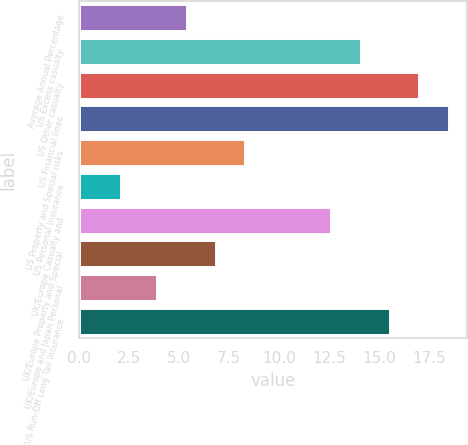Convert chart. <chart><loc_0><loc_0><loc_500><loc_500><bar_chart><fcel>Average Annual Percentage<fcel>US Excess casualty<fcel>US Other casualty<fcel>US Financial lines<fcel>US Property and Special risks<fcel>US Personal Insurance<fcel>UK/Europe Casualty and<fcel>UK/Europe Property and Special<fcel>UK/Europe and Japan Personal<fcel>US Run-Off Long Tail Insurance<nl><fcel>5.37<fcel>14.07<fcel>17.01<fcel>18.48<fcel>8.31<fcel>2.1<fcel>12.6<fcel>6.84<fcel>3.9<fcel>15.54<nl></chart> 